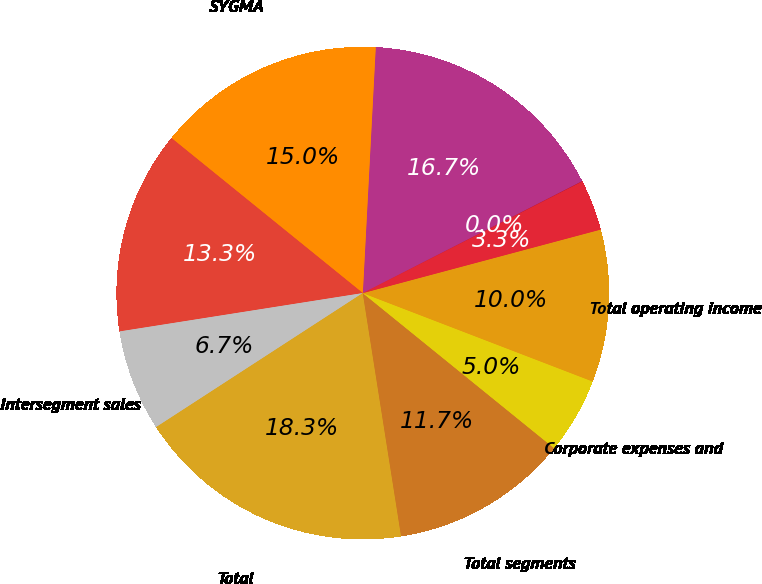<chart> <loc_0><loc_0><loc_500><loc_500><pie_chart><fcel>Broadline<fcel>SYGMA<fcel>Other<fcel>Intersegment sales<fcel>Total<fcel>Total segments<fcel>Corporate expenses and<fcel>Total operating income<fcel>Interest expense<fcel>Other income net<nl><fcel>16.66%<fcel>15.0%<fcel>13.33%<fcel>6.67%<fcel>18.33%<fcel>11.67%<fcel>5.0%<fcel>10.0%<fcel>3.34%<fcel>0.01%<nl></chart> 